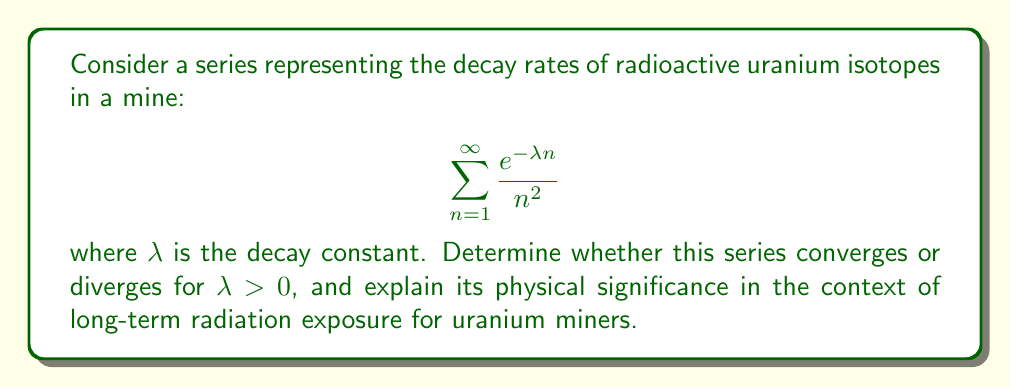Can you solve this math problem? To analyze the convergence of this series, we'll use the comparison test and the limit comparison test.

1) First, observe that for $\lambda > 0$ and $n \geq 1$, we have $0 < e^{-\lambda n} \leq 1$.

2) This allows us to compare our series with the p-series $\sum_{n=1}^{\infty} \frac{1}{n^2}$:

   $$0 < \frac{e^{-\lambda n}}{n^2} \leq \frac{1}{n^2}$$

3) We know that $\sum_{n=1}^{\infty} \frac{1}{n^2}$ converges (it's the Basel problem, with sum $\frac{\pi^2}{6}$).

4) By the comparison test, our series also converges for all $\lambda > 0$.

5) To get more insight, let's use the limit comparison test with $a_n = \frac{e^{-\lambda n}}{n^2}$ and $b_n = \frac{1}{n^2}$:

   $$\lim_{n \to \infty} \frac{a_n}{b_n} = \lim_{n \to \infty} e^{-\lambda n} = 0$$

6) This shows that our series converges even faster than $\sum_{n=1}^{\infty} \frac{1}{n^2}$ for any $\lambda > 0$.

Physical significance:
The convergence of this series indicates that the cumulative effect of radiation exposure from decaying uranium isotopes over an infinite time period is finite. This is crucial for assessing long-term occupational health risks for uranium miners. The faster convergence for larger $\lambda$ values suggests that isotopes with higher decay rates (shorter half-lives) contribute less to long-term exposure, while those with smaller decay rates (longer half-lives) pose more significant long-term risks.
Answer: The series $\sum_{n=1}^{\infty} \frac{e^{-\lambda n}}{n^2}$ converges for all $\lambda > 0$. 